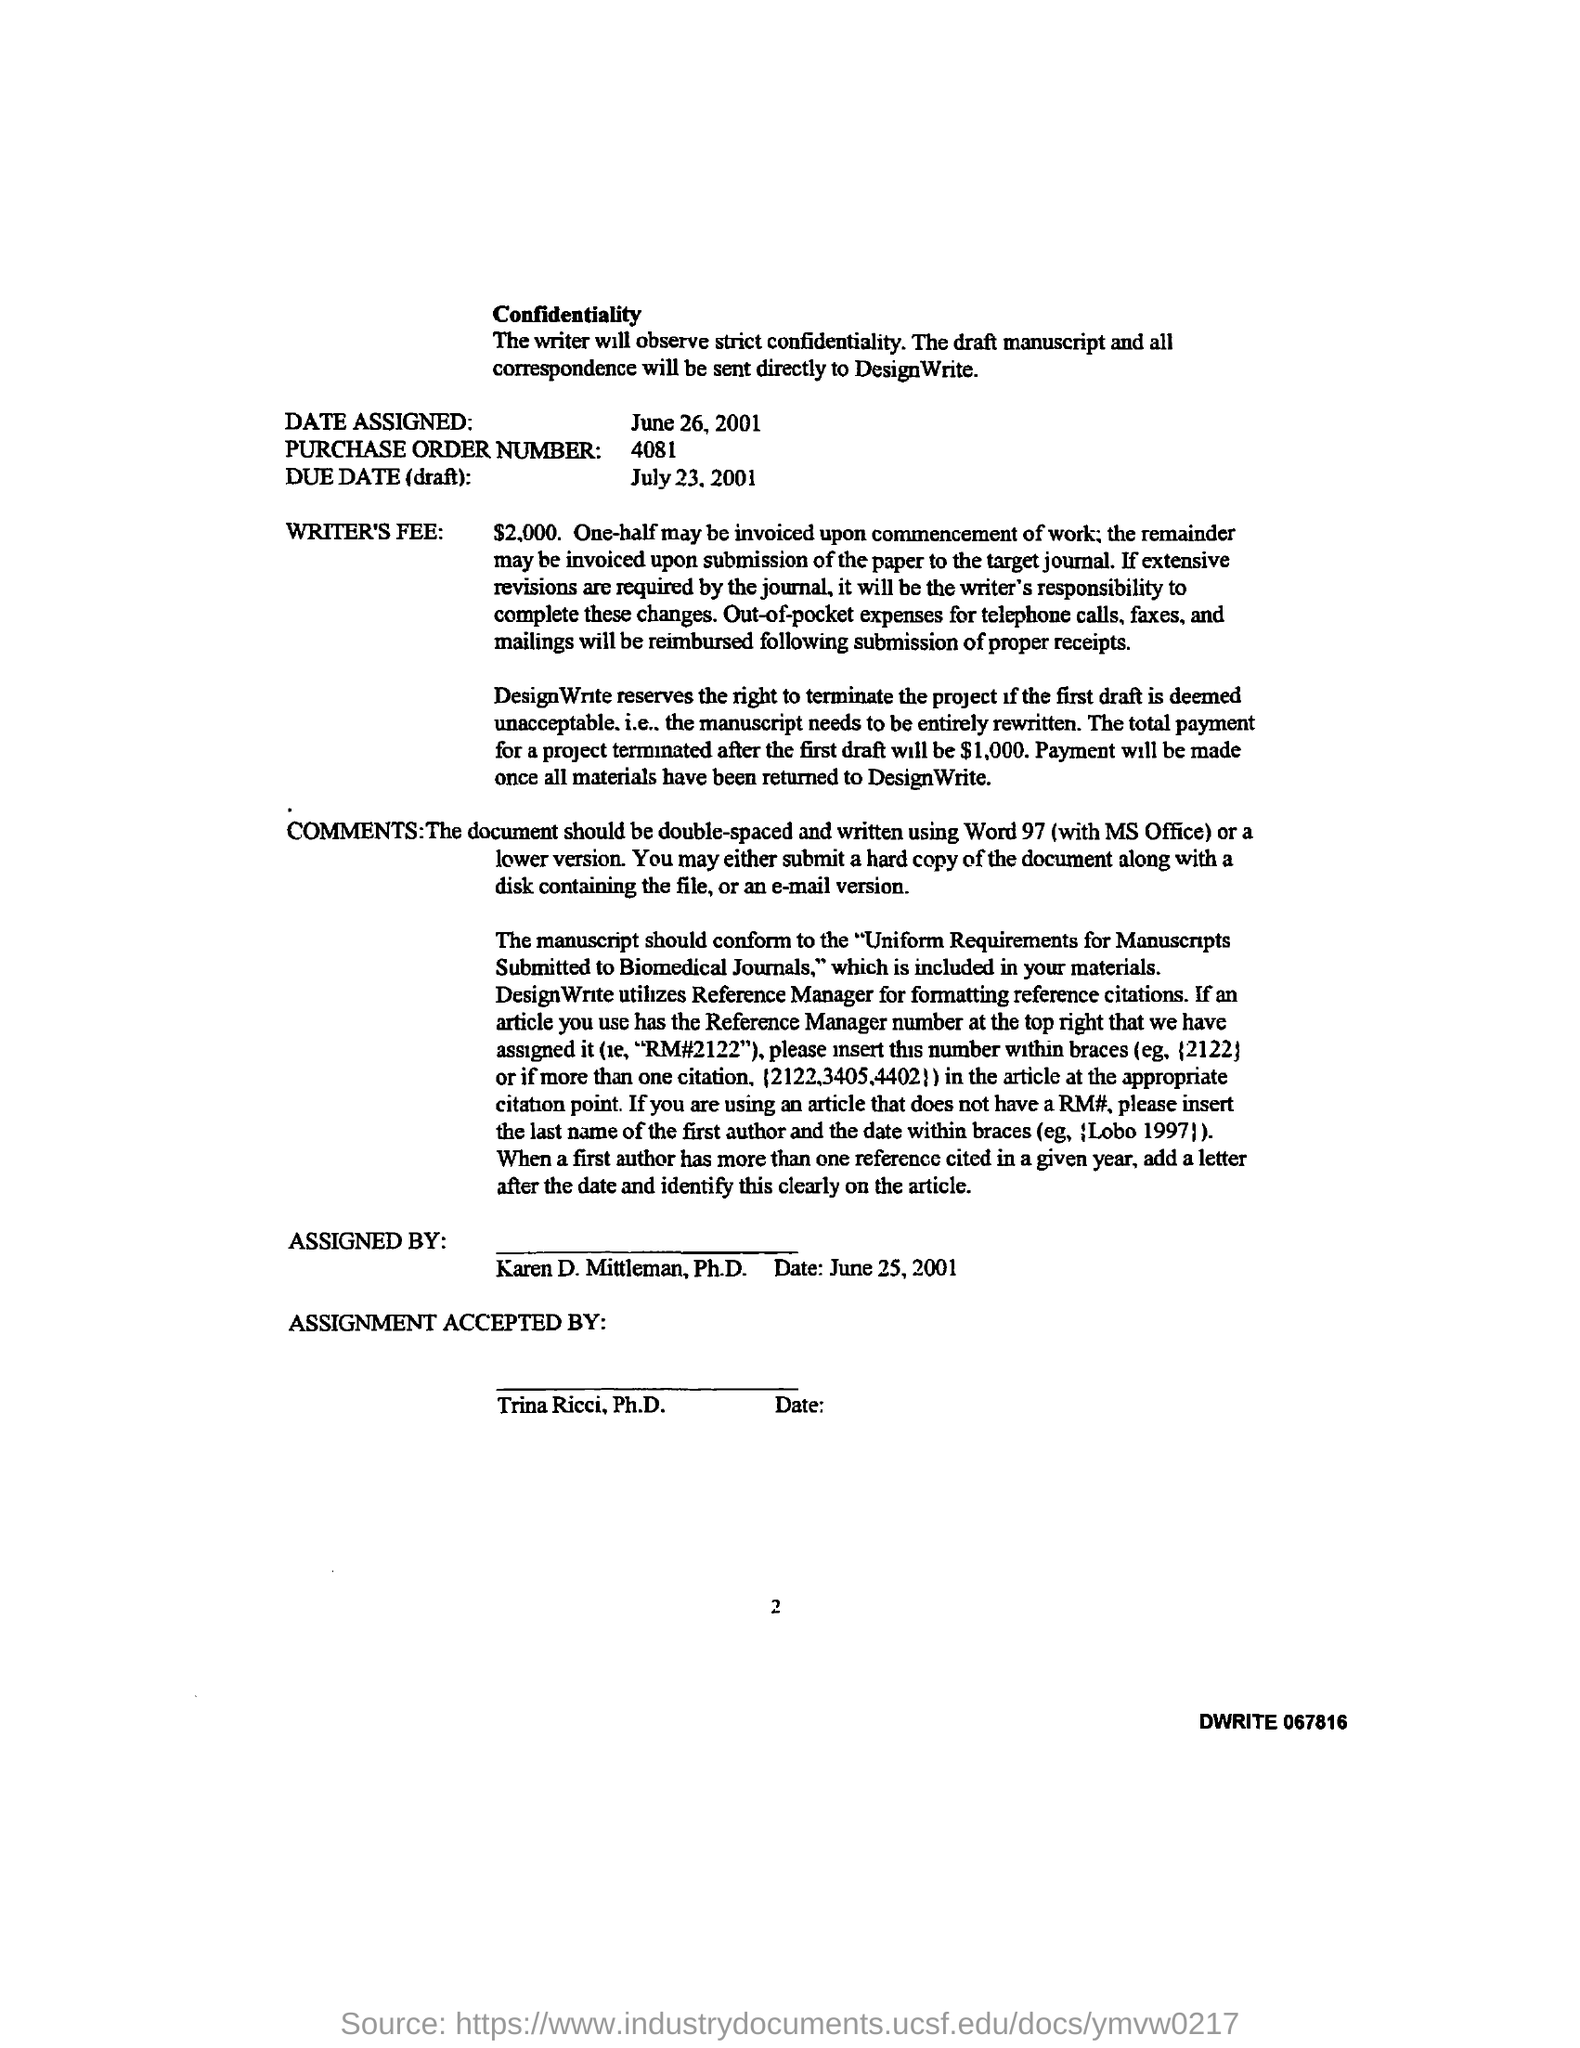What is the due date (draft) mentioned in the given letter ?
Your answer should be compact. July 23, 2001. What is the purchased order number mentioned in the given letter ?
Make the answer very short. 4081. When is the date assigned in the given letter ?
Offer a terse response. June 26, 2001. By whom the assignment accepted by in the given letter ?
Your response must be concise. Trina Ricci. To whom this letter was assigned by ?
Provide a succinct answer. Karen D. Mittleman. What is the writer's fee mentioned in the given letter ?
Your answer should be very brief. 2,000. What will be the total payment for a project terminated after the first draft ?
Your answer should be compact. 1,000. When is the date assigned in the given letter ?
Your response must be concise. June 26, 2001. 